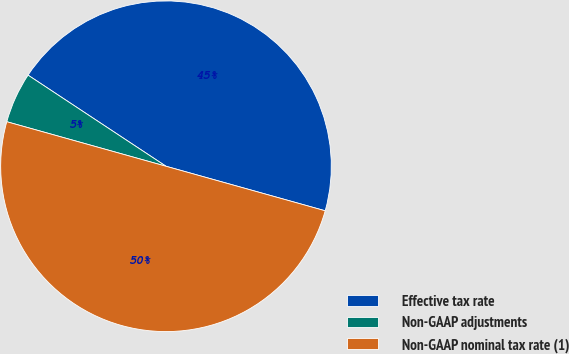Convert chart. <chart><loc_0><loc_0><loc_500><loc_500><pie_chart><fcel>Effective tax rate<fcel>Non-GAAP adjustments<fcel>Non-GAAP nominal tax rate (1)<nl><fcel>45.05%<fcel>4.95%<fcel>50.0%<nl></chart> 